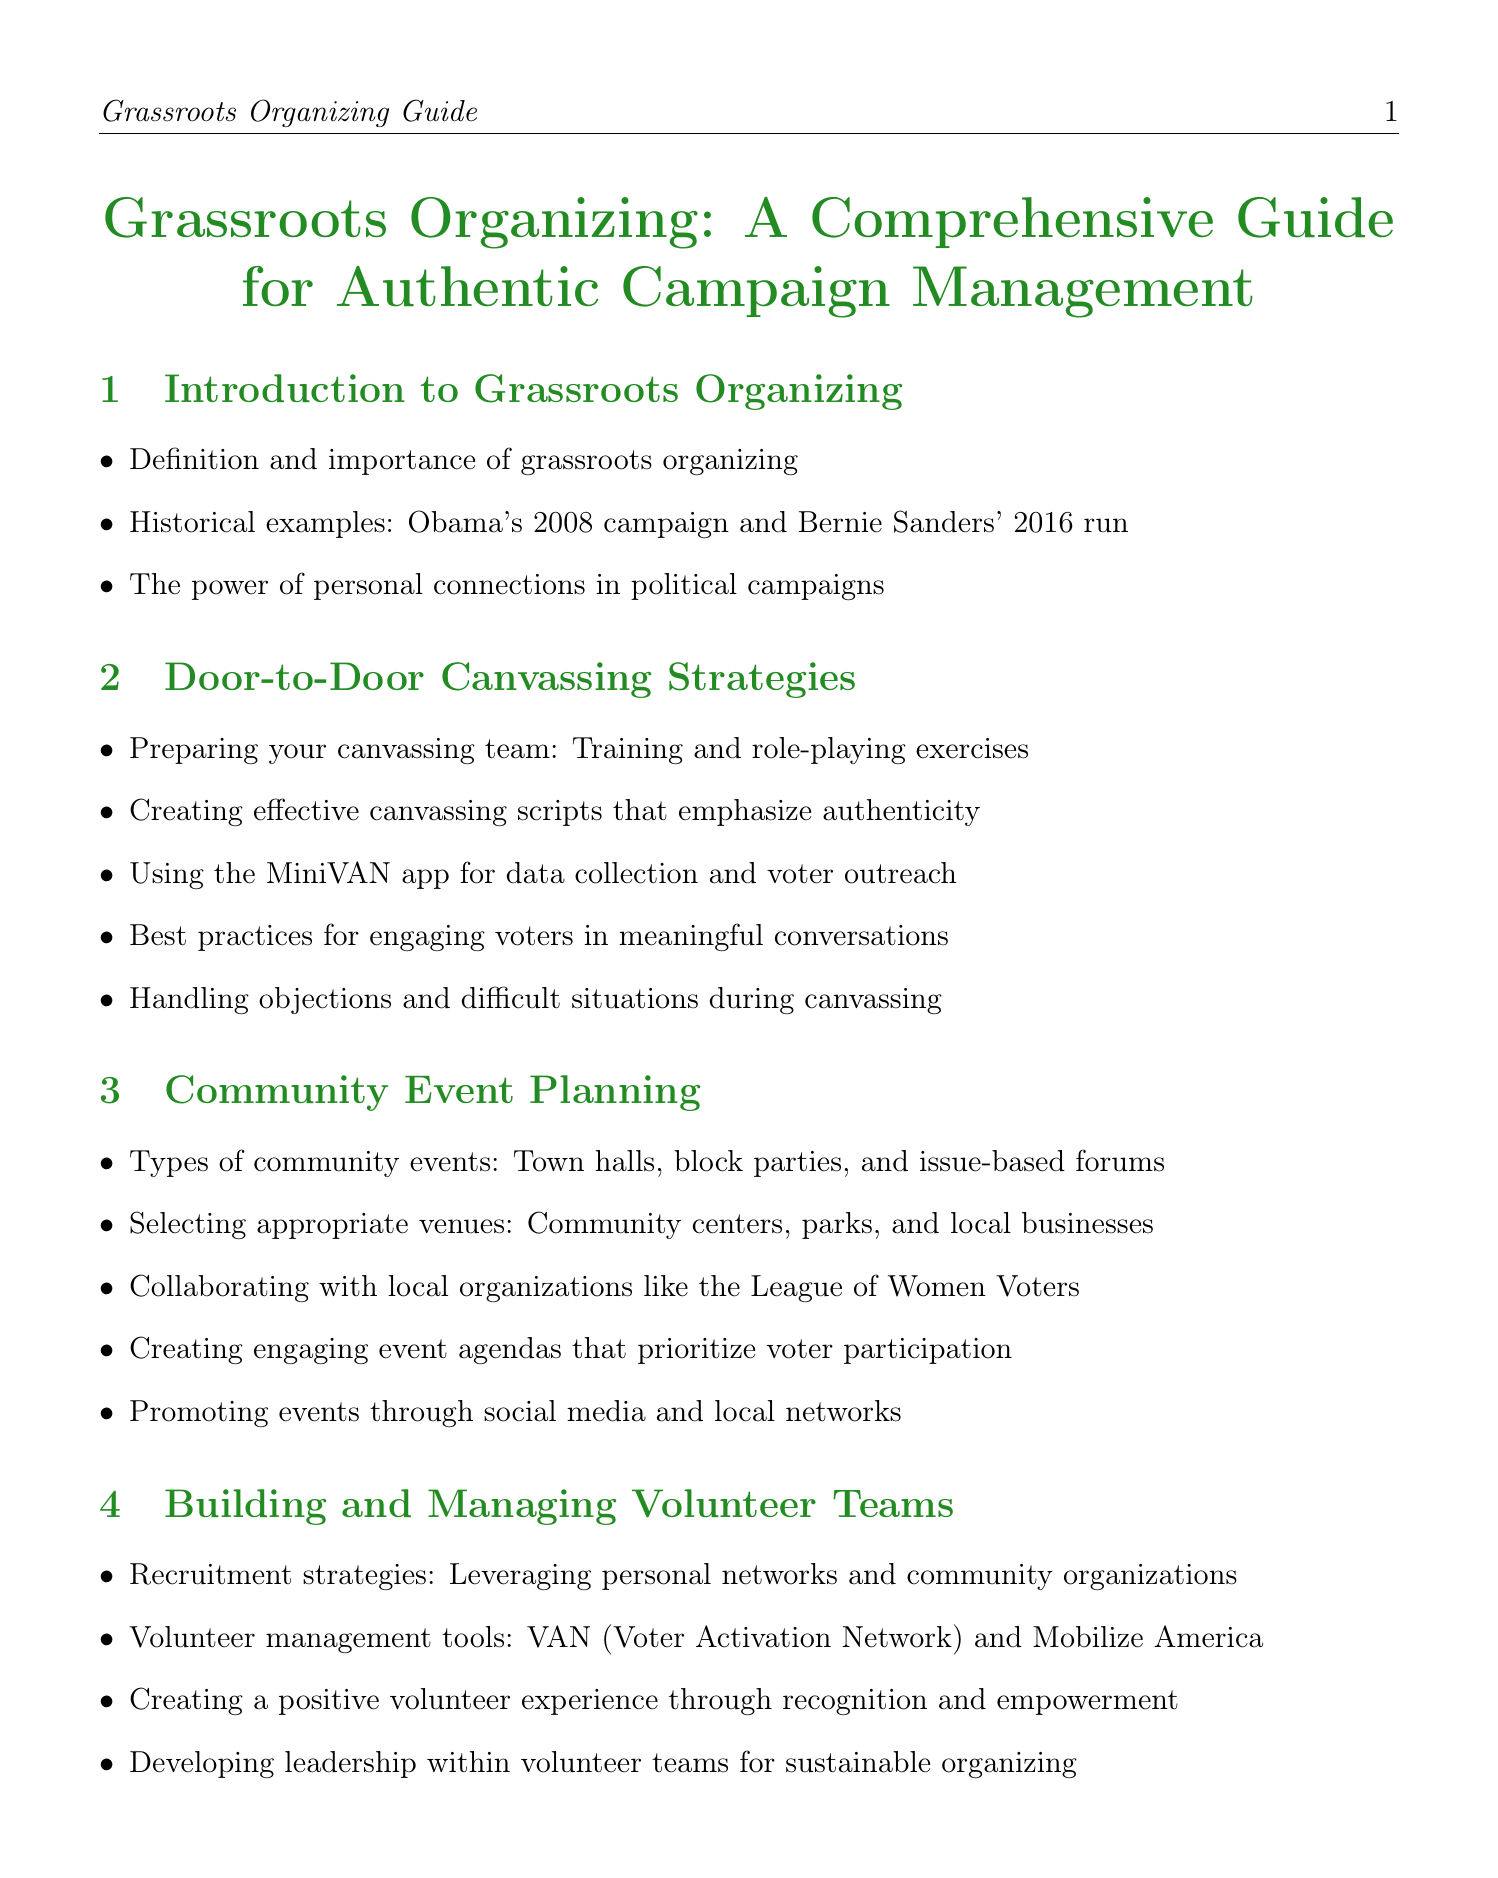What is the title of the manual? The title of the manual is explicitly provided at the beginning of the document.
Answer: Grassroots Organizing: A Comprehensive Guide for Authentic Campaign Management How many sections are in the manual? The manual contains 10 distinct sections as listed in the document.
Answer: 10 What is one historical example of grassroots organizing mentioned? The document cites specific historical examples to illustrate effective grassroots organizing.
Answer: Obama's 2008 campaign What tool is recommended for data collection during canvassing? The manual provides specific tools for effective grassroots organizing efforts.
Answer: MiniVAN Which type of event is suggested for community engagement in the manual? The manual outlines various types of community events for outreach purposes.
Answer: Town halls What is a strategy for building volunteer teams mentioned in the manual? The document suggests various strategies to recruit and manage volunteers effectively.
Answer: Leveraging personal networks What is one technique for engaging voters during canvassing? The manual lists best practices aimed at improving voter interactions during canvassing.
Answer: Engaging voters in meaningful conversations What should be included in messaging for authenticity? The manual emphasizes the importance of personal connections in campaign messaging.
Answer: Personal stories and testimonials from community members Which compliance aspect is highlighted in the legal and ethical considerations section? The document outlines important legal considerations relevant to campaign management.
Answer: Campaign finance laws What type of metrics should be used to evaluate grassroots efforts? The manual specifies using various tools to measure the success of campaign activities.
Answer: Key performance indicators (KPIs) 